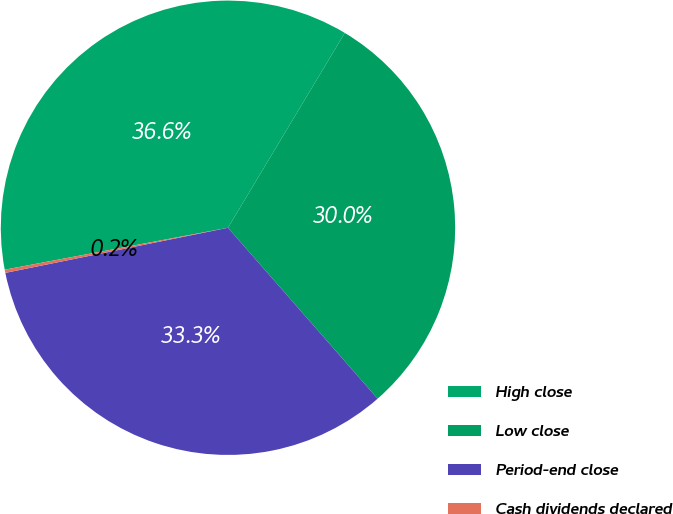Convert chart. <chart><loc_0><loc_0><loc_500><loc_500><pie_chart><fcel>High close<fcel>Low close<fcel>Period-end close<fcel>Cash dividends declared<nl><fcel>36.55%<fcel>29.96%<fcel>33.26%<fcel>0.23%<nl></chart> 